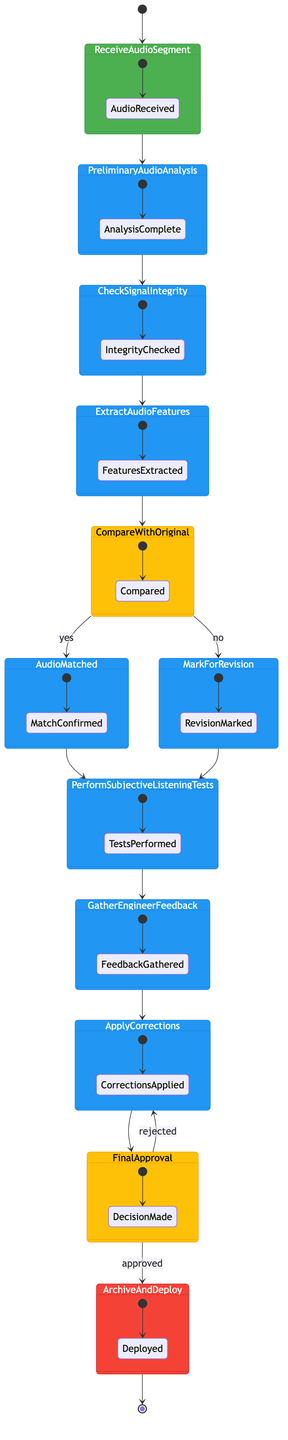What is the starting node of the diagram? The starting node is indicated by the type "start," which is labeled as "Receive Audio Segment." This is the first activity that initiates the process.
Answer: Receive Audio Segment How many decision nodes are present in the diagram? The diagram includes two decision nodes: "Compare with Original" and "Final Approval." Each decision node is represented by a diamond shape in activity diagrams.
Answer: 2 What is the output when the "Final Approval" is approved? According to the flow of the diagram, if "Final Approval" is approved, the process will move to the end node labeled "Archive and Deploy." The output represents the successful completion of the process.
Answer: Archive and Deploy What is the action that follows "Audio Matched"? After "Audio Matched," the next action in the sequence is "Perform Subjective Listening Tests." The diagram flows from one action to the next, clearly indicating this transition.
Answer: Perform Subjective Listening Tests Can "Mark for Revision" lead to another action? If yes, which one? Yes, "Mark for Revision" leads to "Perform Subjective Listening Tests." Both branches from the decision node connect to this action, indicating that regardless of whether the audio matches or not, listening tests will be performed afterwards.
Answer: Perform Subjective Listening Tests Which node represents the final step in the process? The final step in the process is represented by the node labeled "Archive and Deploy," indicated by the type "end." This signifies the completion of the quality assurance process.
Answer: Archive and Deploy What is the first action taken after receiving an audio segment? The first action taken after receiving an audio segment is "Preliminary Audio Analysis." This is the next step following the initiation of the process.
Answer: Preliminary Audio Analysis What happens if corrections are rejected during the "Final Approval"? If the corrections are rejected during the "Final Approval," the process loops back to the "Apply Corrections" action. This ensures that revisions can be made before final approval is granted.
Answer: Apply Corrections How many actions are there between the start and end nodes? To determine the number of actions, we count all the action nodes from "Preliminary Audio Analysis" to "Apply Corrections" before reaching the final node. There are 8 action nodes in total.
Answer: 8 